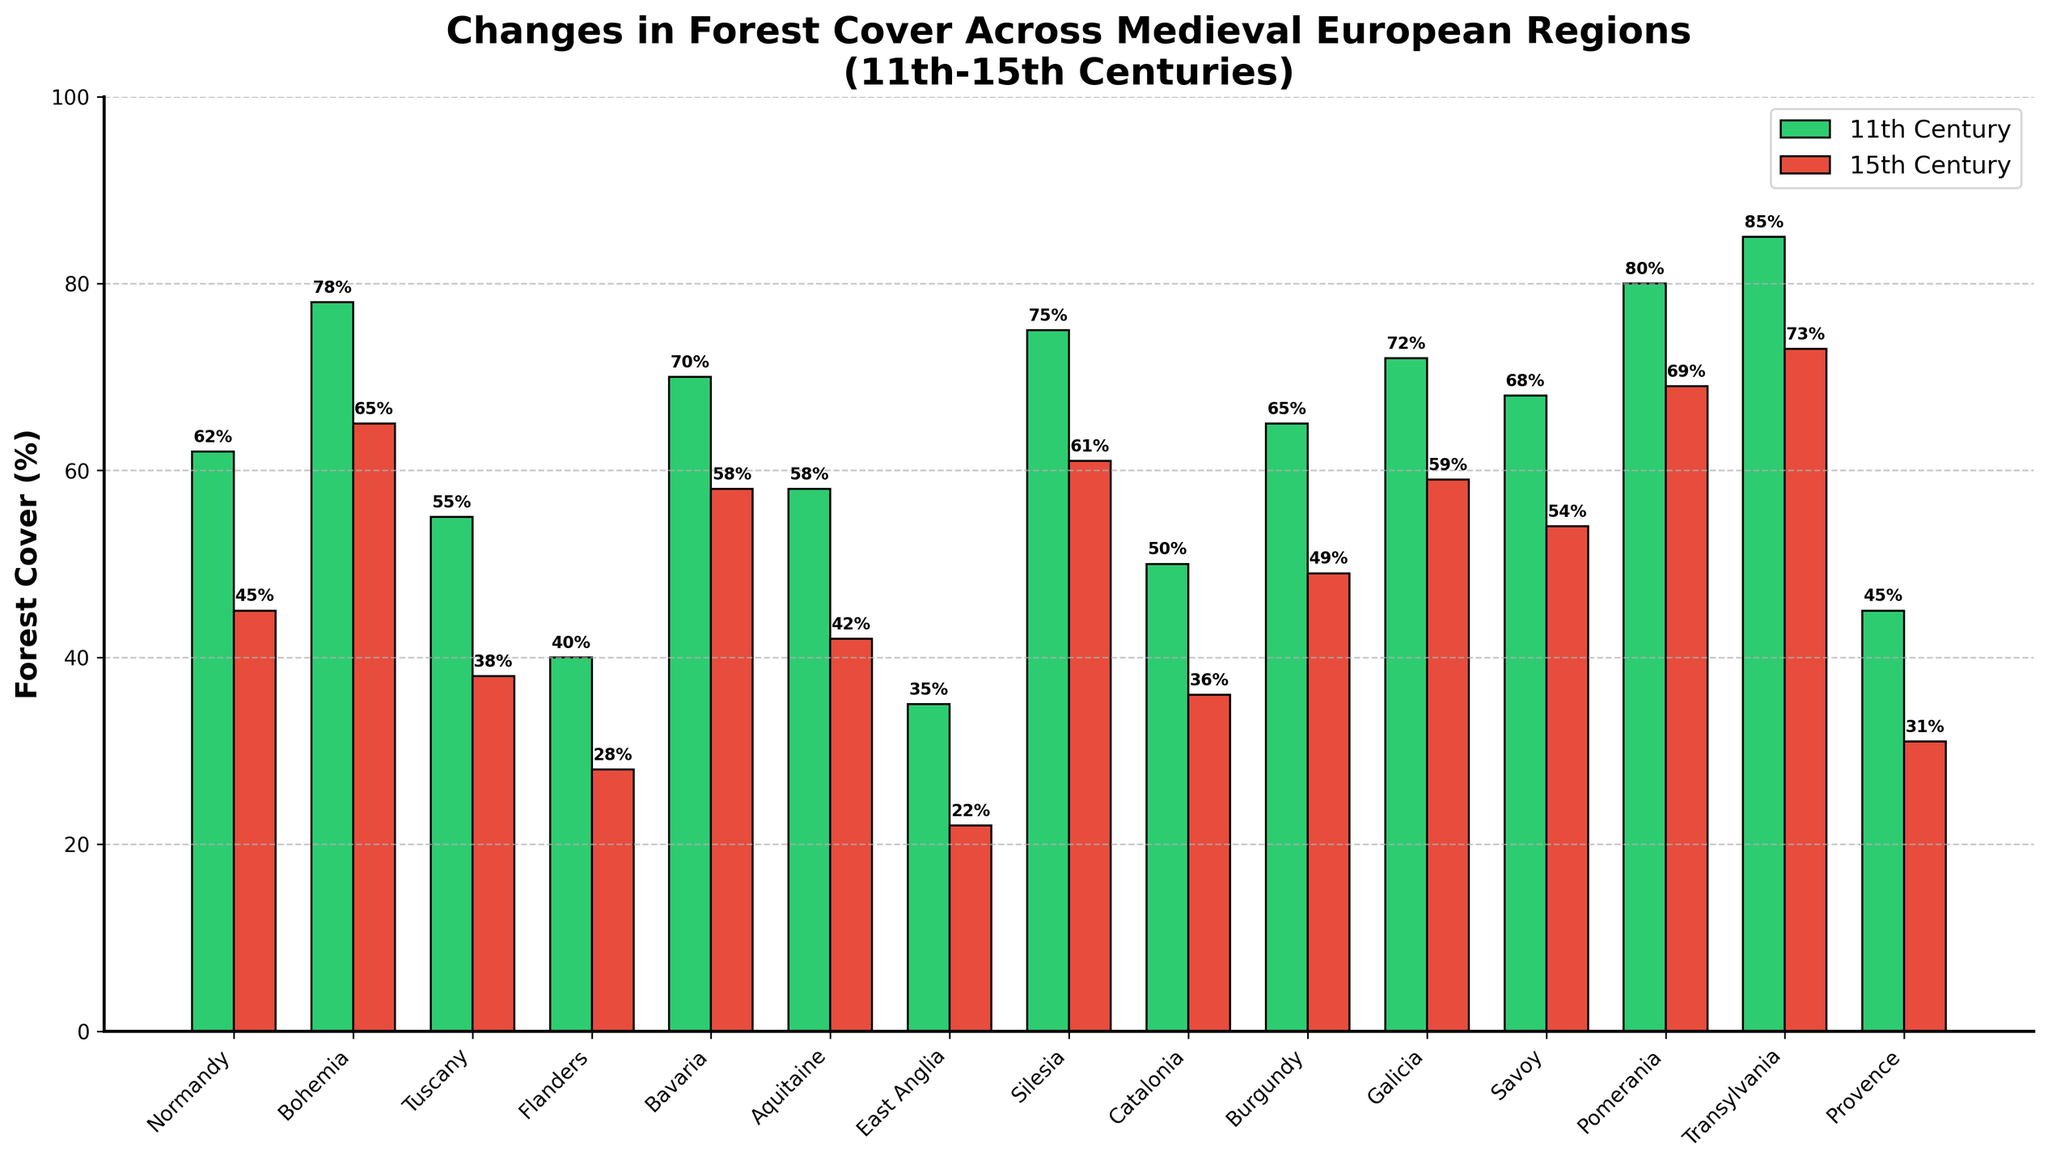What's the difference in forest cover between the 11th and 15th centuries for Normandy? From the bar chart, the forest cover in Normandy was 62% in the 11th century and decreased to 45% in the 15th century. The difference is 62% - 45% = 17%.
Answer: 17% Which region experienced the greatest reduction in forest cover from the 11th to the 15th century? By visually comparing the lengths of the red and green bars, we see that Tuscany had the greatest reduction in forest cover, with a decrease from 55% in the 11th century to 38% in the 15th century, a difference of 17%.
Answer: Tuscany How many regions had less than 40% forest cover in the 15th century? By counting the red bars that fall below the 40% mark, we see that there are five regions: Flanders, East Anglia, Catalonia, Provence, and Tuscany.
Answer: 5 Which region had the highest forest cover in the 15th century, and what was the percentage? By comparing the highest points of the red bars, the highest 15th-century forest cover is in Transylvania with 73%.
Answer: Transylvania, 73% What is the average forest cover percentage across all regions in the 11th century? Adding the forest cover percentages for all regions in the 11th century (62 + 78 + 55 + 40 + 70 + 58 + 35 + 75 + 50 + 65 + 72 + 68 + 80 + 85 + 45) and dividing by the number of regions (15) gives the average (938 / 15) = 62.53%.
Answer: 62.53% Compare the forest cover change between Bohemia and Burgundy from the 11th to the 15th century. Which one had a larger absolute change? For Bohemia, the forest cover changed from 78% to 65%, a decrease of 13%. For Burgundy, it changed from 65% to 49%, a decrease of 16%. Burgundy had a larger absolute change.
Answer: Burgundy Which region had the smallest change in forest cover from the 11th to the 15th century? By comparing the differences for each region, Pomerania had the smallest change in forest cover, decreasing from 80% to 69%, a change of 11%.
Answer: Pomerania How many regions had a greater decrease in forest cover than Bavaria from the 11th to the 15th century? Bavaria's forest cover decreased from 70% to 58%, a decrease of 12%. By comparing the decreases, seven regions (Normandy, Bohemia, Tuscany, Flanders, Aquitaine, Silesia, Burgundy) had a greater decrease than Bavaria.
Answer: 7 